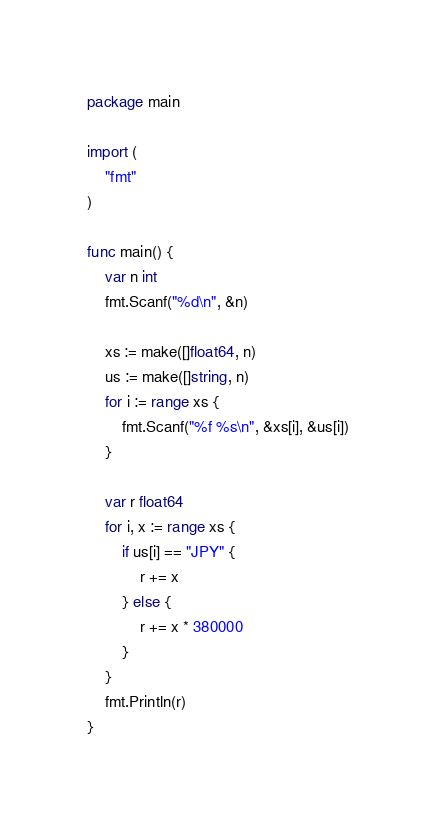<code> <loc_0><loc_0><loc_500><loc_500><_Go_>package main

import (
	"fmt"
)

func main() {
	var n int
	fmt.Scanf("%d\n", &n)

	xs := make([]float64, n)
	us := make([]string, n)
	for i := range xs {
		fmt.Scanf("%f %s\n", &xs[i], &us[i])
	}

	var r float64
	for i, x := range xs {
		if us[i] == "JPY" {
			r += x
		} else {
			r += x * 380000
		}
	}
	fmt.Println(r)
}</code> 